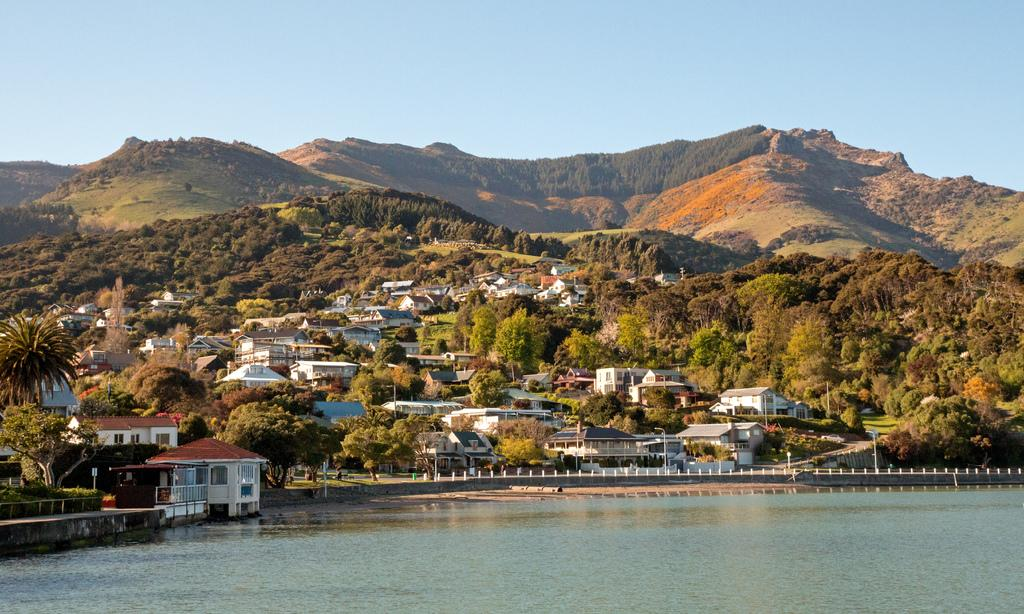What is happening in the image? There is water flowing in the image. What type of structures can be seen in the image? There are houses in the image. What type of vegetation is present in the image? Trees and bushes are visible in the image. What type of pathway can be seen in the image? There appears to be a road in the image. What type of geographical feature is visible in the image? There are mountains in the image. What type of cheese is being produced by the machine in the image? There is no machine or cheese present in the image. How does the steam escape from the cheese in the image? There is no steam or cheese present in the image. 